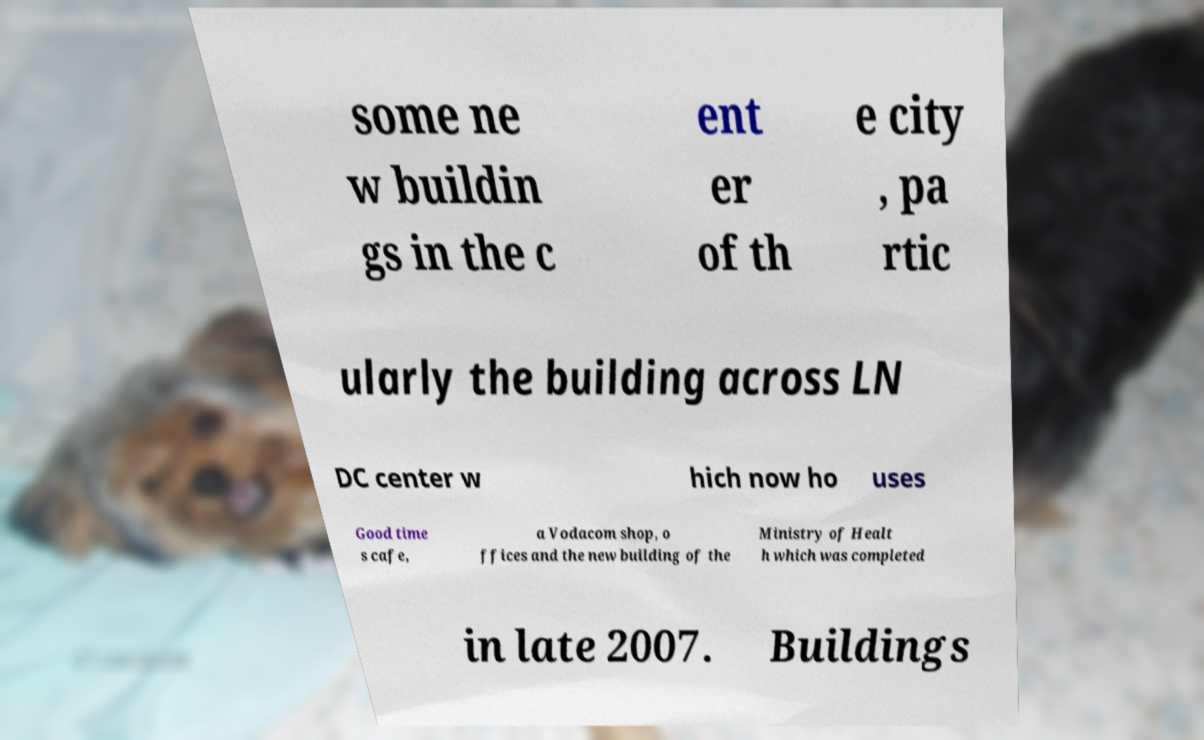There's text embedded in this image that I need extracted. Can you transcribe it verbatim? some ne w buildin gs in the c ent er of th e city , pa rtic ularly the building across LN DC center w hich now ho uses Good time s cafe, a Vodacom shop, o ffices and the new building of the Ministry of Healt h which was completed in late 2007. Buildings 